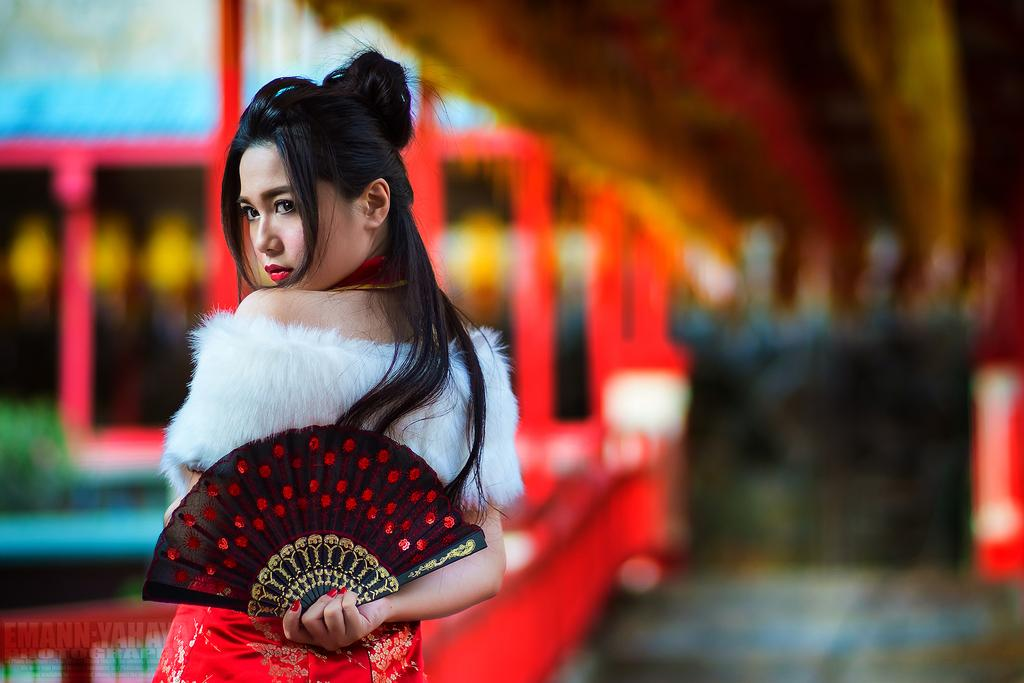What is the main subject of the image? There is a lady standing in the image. What is the lady holding in the image? The lady is holding a hand fan. Can you describe the background of the image? The background of the image is blurry. What type of print can be seen on the lady's breakfast in the image? There is no breakfast present in the image, so it is not possible to determine if there is any print on it. 